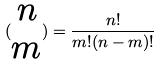<formula> <loc_0><loc_0><loc_500><loc_500>( \begin{matrix} n \\ m \end{matrix} ) = \frac { n ! } { m ! ( n - m ) ! }</formula> 